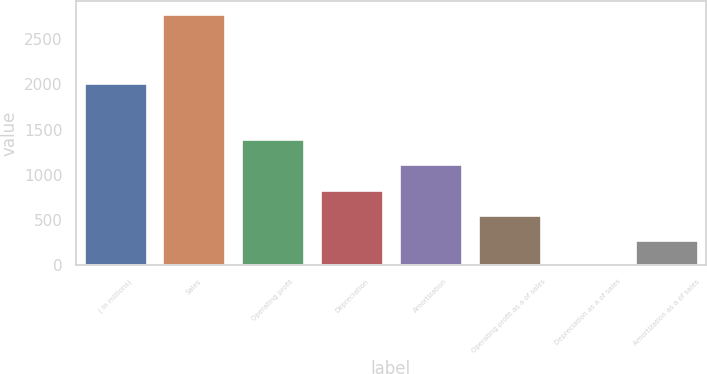<chart> <loc_0><loc_0><loc_500><loc_500><bar_chart><fcel>( in millions)<fcel>Sales<fcel>Operating profit<fcel>Depreciation<fcel>Amortization<fcel>Operating profit as a of sales<fcel>Depreciation as a of sales<fcel>Amortization as a of sales<nl><fcel>2016<fcel>2785.4<fcel>1393.5<fcel>836.74<fcel>1115.12<fcel>558.36<fcel>1.6<fcel>279.98<nl></chart> 